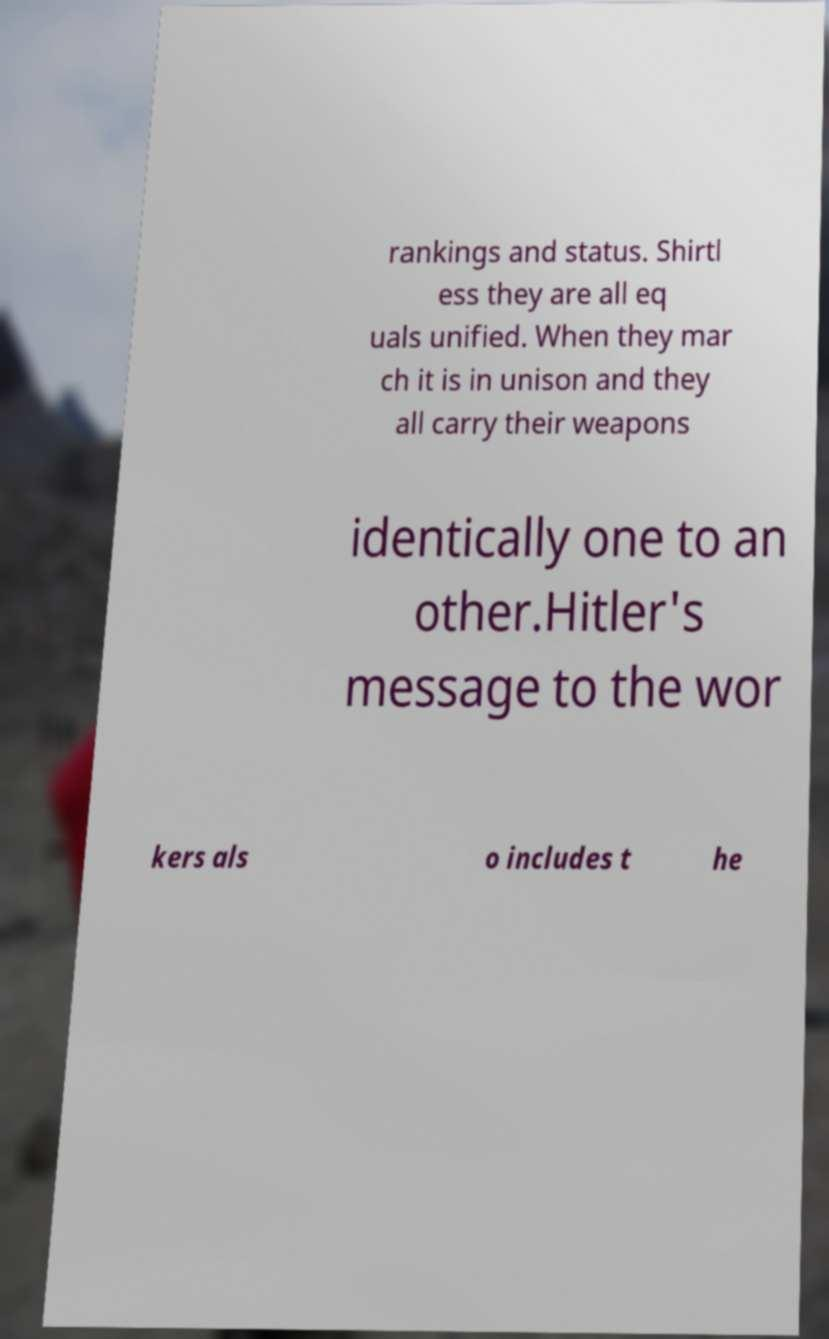Please read and relay the text visible in this image. What does it say? rankings and status. Shirtl ess they are all eq uals unified. When they mar ch it is in unison and they all carry their weapons identically one to an other.Hitler's message to the wor kers als o includes t he 